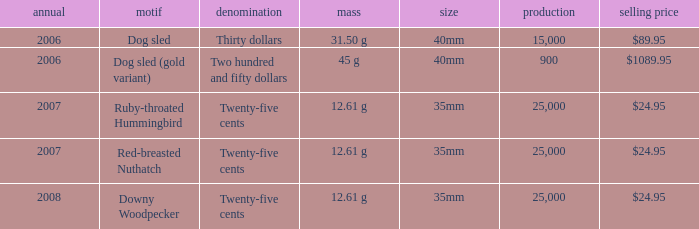What is the Year of the Coin with an Issue Price of $1089.95 and Mintage less than 900? None. 